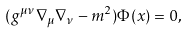<formula> <loc_0><loc_0><loc_500><loc_500>( g ^ { \mu \nu } \nabla _ { \mu } \nabla _ { \nu } - m ^ { 2 } ) \Phi { ( x ) } = 0 { , }</formula> 